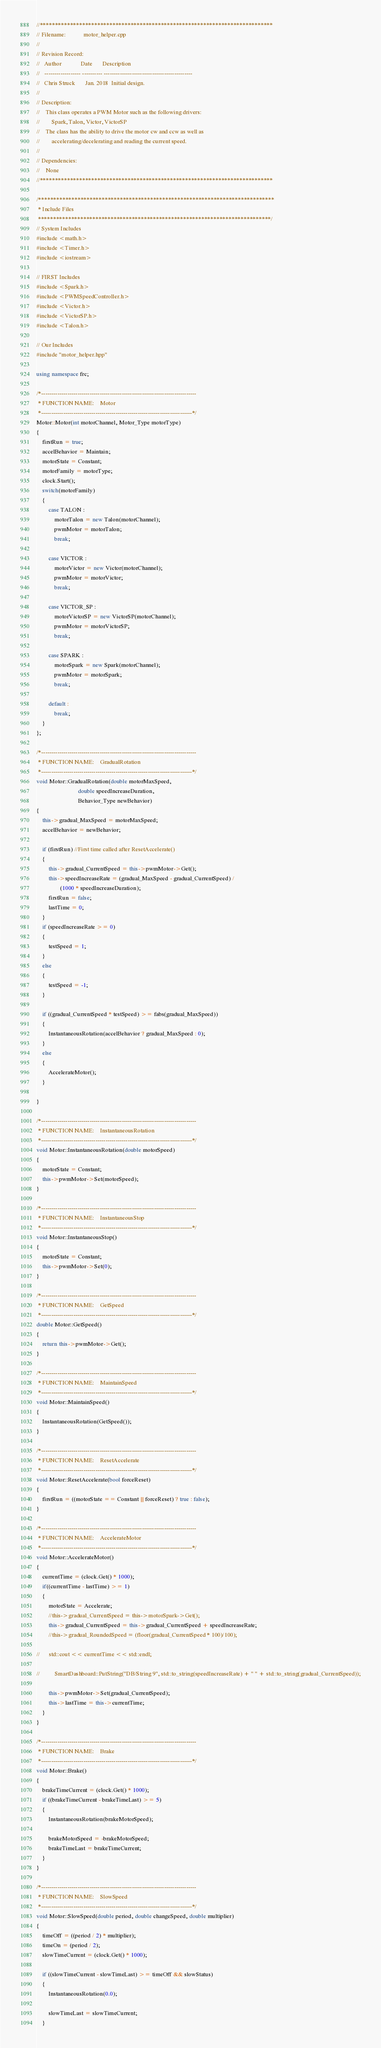<code> <loc_0><loc_0><loc_500><loc_500><_C++_>//*****************************************************************************
// Filename:            motor_helper.cpp
//
// Revision Record:
//   Author             Date       Description
//   ------------------ ---------- --------------------------------------------
//   Chris Struck       Jan. 2018  Initial design.
//
// Description:
//    This class operates a PWM Motor such as the following drivers:
//        Spark, Talon, Victor, VictorSP
//    The class has the ability to drive the motor cw and ccw as well as
//        accelerating/decelerating and reading the current speed.
// 
// Dependencies:
//    None
//*****************************************************************************

/******************************************************************************
 * Include Files
 *****************************************************************************/
// System Includes
#include <math.h>
#include <Timer.h>
#include <iostream>

// FIRST Includes
#include <Spark.h>
#include <PWMSpeedController.h>
#include <Victor.h>
#include <VictorSP.h>
#include <Talon.h>

// Our Includes
#include "motor_helper.hpp"

using namespace frc;

/*-----------------------------------------------------------------------------
 * FUNCTION NAME:    Motor
 *---------------------------------------------------------------------------*/
Motor::Motor(int motorChannel, Motor_Type motorType)
{
	firstRun = true;
	accelBehavior = Maintain;
	motorState = Constant;
	motorFamily = motorType;
	clock.Start();
	switch(motorFamily)
	{
		case TALON :
			motorTalon = new Talon(motorChannel);
			pwmMotor = motorTalon;
			break;

		case VICTOR :
			motorVictor = new Victor(motorChannel);
			pwmMotor = motorVictor;
			break;

		case VICTOR_SP :
			motorVictorSP = new VictorSP(motorChannel);
			pwmMotor = motorVictorSP;
			break;

		case SPARK :
			motorSpark = new Spark(motorChannel);
			pwmMotor = motorSpark;
			break;

		default :
			break;
	}
};

/*-----------------------------------------------------------------------------
 * FUNCTION NAME:    GradualRotation
 *---------------------------------------------------------------------------*/
void Motor::GradualRotation(double motorMaxSpeed,
							double speedIncreaseDuration,
							Behavior_Type newBehavior)
{
	this->gradual_MaxSpeed = motorMaxSpeed;
	accelBehavior = newBehavior;

	if (firstRun) //First time called after ResetAccelerate()
	{
		this->gradual_CurrentSpeed = this->pwmMotor->Get();
		this->speedIncreaseRate = (gradual_MaxSpeed - gradual_CurrentSpeed) /
				(1000 * speedIncreaseDuration);
		firstRun = false;
		lastTime = 0;
	}
	if (speedIncreaseRate >= 0)
	{
		testSpeed = 1;
	}
	else
	{
		testSpeed = -1;
	}

	if ((gradual_CurrentSpeed * testSpeed) >= fabs(gradual_MaxSpeed))
	{
		InstantaneousRotation(accelBehavior ? gradual_MaxSpeed : 0);
	}
	else
	{
		AccelerateMotor();
	}

}

/*-----------------------------------------------------------------------------
 * FUNCTION NAME:    InstantaneousRotation
 *---------------------------------------------------------------------------*/
void Motor::InstantaneousRotation(double motorSpeed)
{
	motorState = Constant;
	this->pwmMotor->Set(motorSpeed);
}

/*-----------------------------------------------------------------------------
 * FUNCTION NAME:    InstantaneousStop
 *---------------------------------------------------------------------------*/
void Motor::InstantaneousStop()
{
	motorState = Constant;
	this->pwmMotor->Set(0);
}

/*-----------------------------------------------------------------------------
 * FUNCTION NAME:    GetSpeed
 *---------------------------------------------------------------------------*/
double Motor::GetSpeed()
{
	return this->pwmMotor->Get();
}

/*-----------------------------------------------------------------------------
 * FUNCTION NAME:    MaintainSpeed
 *---------------------------------------------------------------------------*/
void Motor::MaintainSpeed()
{
	InstantaneousRotation(GetSpeed());
}

/*-----------------------------------------------------------------------------
 * FUNCTION NAME:    ResetAccelerate
 *---------------------------------------------------------------------------*/
void Motor::ResetAccelerate(bool forceReset)
{
	firstRun = ((motorState == Constant || forceReset) ? true : false);
}

/*-----------------------------------------------------------------------------
 * FUNCTION NAME:    AccelerateMotor
 *---------------------------------------------------------------------------*/
void Motor::AccelerateMotor()
{
	currentTime = (clock.Get() * 1000);
	if((currentTime - lastTime) >= 1)
	{
		motorState = Accelerate;
		//this->gradual_CurrentSpeed = this->motorSpark->Get();
		this->gradual_CurrentSpeed = this->gradual_CurrentSpeed + speedIncreaseRate;
		//this->gradual_RoundedSpeed = (floor(gradual_CurrentSpeed * 100)/100);

//		std::cout << currentTime << std::endl;

//			SmartDashboard::PutString("DB/String 9", std::to_string(speedIncreaseRate) + " " + std::to_string(gradual_CurrentSpeed));

		this->pwmMotor->Set(gradual_CurrentSpeed);
		this->lastTime = this->currentTime;
	}
}

/*-----------------------------------------------------------------------------
 * FUNCTION NAME:    Brake
 *---------------------------------------------------------------------------*/
void Motor::Brake()
{
	brakeTimeCurrent = (clock.Get() * 1000);
	if ((brakeTimeCurrent - brakeTimeLast) >= 5)
	{
		InstantaneousRotation(brakeMotorSpeed);

		brakeMotorSpeed = -brakeMotorSpeed;
		brakeTimeLast = brakeTimeCurrent;
	}
}

/*-----------------------------------------------------------------------------
 * FUNCTION NAME:    SlowSpeed
 *---------------------------------------------------------------------------*/
void Motor::SlowSpeed(double period, double changeSpeed, double multiplier)
{
	timeOff = ((period / 2) * multiplier);
	timeOn = (period / 2);
	slowTimeCurrent = (clock.Get() * 1000);

	if ((slowTimeCurrent - slowTimeLast) >= timeOff && slowStatus)
	{
		InstantaneousRotation(0.0);

		slowTimeLast = slowTimeCurrent;
	}</code> 